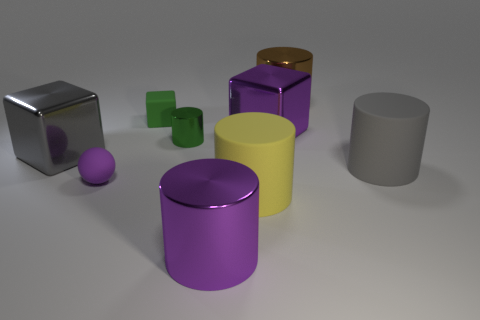Subtract all yellow cylinders. How many cylinders are left? 4 Subtract 2 cylinders. How many cylinders are left? 3 Subtract all brown cylinders. How many cylinders are left? 4 Add 1 small green blocks. How many objects exist? 10 Subtract all gray cylinders. Subtract all blue balls. How many cylinders are left? 4 Subtract all cubes. How many objects are left? 6 Subtract all green matte things. Subtract all tiny green cubes. How many objects are left? 7 Add 5 big yellow matte objects. How many big yellow matte objects are left? 6 Add 2 tiny green objects. How many tiny green objects exist? 4 Subtract 0 cyan blocks. How many objects are left? 9 